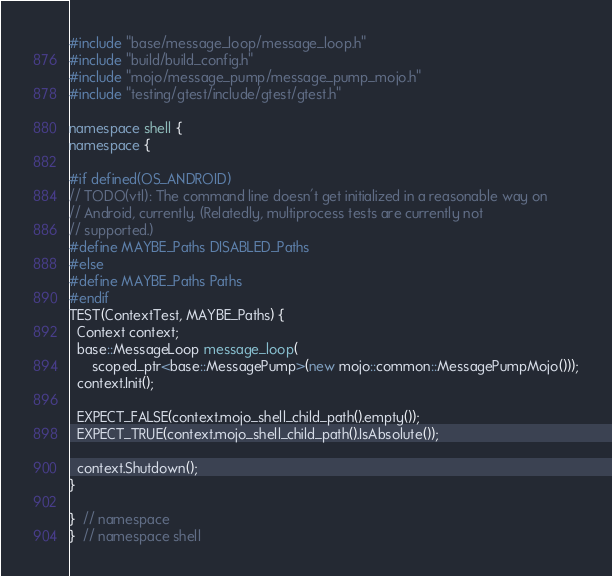Convert code to text. <code><loc_0><loc_0><loc_500><loc_500><_C++_>#include "base/message_loop/message_loop.h"
#include "build/build_config.h"
#include "mojo/message_pump/message_pump_mojo.h"
#include "testing/gtest/include/gtest/gtest.h"

namespace shell {
namespace {

#if defined(OS_ANDROID)
// TODO(vtl): The command line doesn't get initialized in a reasonable way on
// Android, currently. (Relatedly, multiprocess tests are currently not
// supported.)
#define MAYBE_Paths DISABLED_Paths
#else
#define MAYBE_Paths Paths
#endif
TEST(ContextTest, MAYBE_Paths) {
  Context context;
  base::MessageLoop message_loop(
      scoped_ptr<base::MessagePump>(new mojo::common::MessagePumpMojo()));
  context.Init();

  EXPECT_FALSE(context.mojo_shell_child_path().empty());
  EXPECT_TRUE(context.mojo_shell_child_path().IsAbsolute());

  context.Shutdown();
}

}  // namespace
}  // namespace shell
</code> 